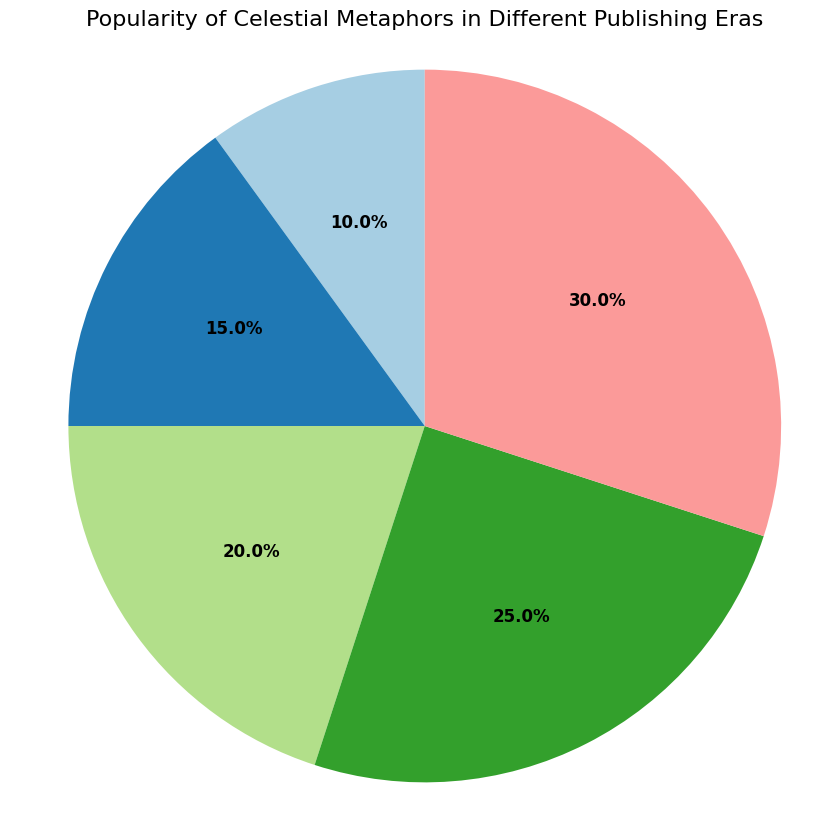What percentage of the pie chart is occupied by the 2020s? The pie chart shows the 2020s segment labeled with a percentage. It is 30% of the whole pie.
Answer: 30% Which era has the smallest piece of the pie chart? By observing the sizes of the pie chart segments, the 1950s have the smallest segment.
Answer: 1950s What is the difference in popularity percentage between the 1990s and the 1950s? The 1990s segment is labeled as 20%, and the 1950s is 10%. The difference is calculated as 20% - 10%.
Answer: 10% What is the sum of the popularity percentages for the eras before the 2000s (1950s, 1970s, and 1990s)? The percentages for these eras are 10% for the 1950s, 15% for the 1970s, and 20% for the 1990s. Adding them together gives 10% + 15% + 20%.
Answer: 45% Between the 1970s and 2010s, which era has a higher popularity percentage, and by how much? The 1970s have a segment labeled 15%, and the 2010s have 25%. The difference is 25% - 15%.
Answer: The 2010s by 10% Does any era have a segment that makes up exactly one-quarter of the pie chart? The segments are labeled with their respective percentages, and the 2010s segment is exactly one-quarter of the pie, which is 25%.
Answer: Yes, the 2010s Considering the colors used in the pie chart, what color is associated with the 1990s? Observe the color used in the segment labeled 1990s.
Answer: [Provide the specific color based on the chart visualization; a placeholder answer is needed without seeing the actual visualization.] What is the ratio of the popularity percentage of the 2020s to the 1950s? The popularity of the 2020s is 30%, and for the 1950s, it is 10%. The ratio is 30% / 10%.
Answer: 3:1 Which two consecutive eras have the least increase in popularity percentage, and what is the value of that increase? Look at the popularity percentages: 1950s to 1970s (10% to 15%), 1970s to 1990s (15% to 20%), 1990s to 2010s (20% to 25%), and 2010s to 2020s (25% to 30%). The smallest increase is between the 1970s and 1990s.
Answer: The 1970s to 1990s, 5% How much more popular are celestial metaphors in the 2020s compared to the 1970s? The percentage for the 2020s is 30%, and for the 1970s, it is 15%. The difference is 30% - 15%.
Answer: 15% 